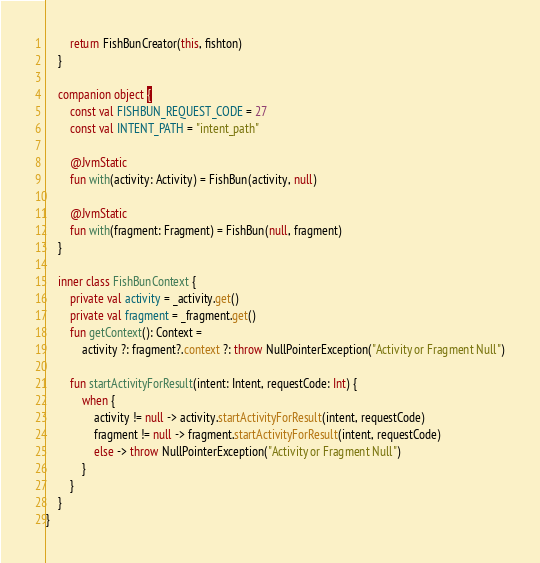<code> <loc_0><loc_0><loc_500><loc_500><_Kotlin_>        return FishBunCreator(this, fishton)
    }

    companion object {
        const val FISHBUN_REQUEST_CODE = 27
        const val INTENT_PATH = "intent_path"

        @JvmStatic
        fun with(activity: Activity) = FishBun(activity, null)

        @JvmStatic
        fun with(fragment: Fragment) = FishBun(null, fragment)
    }

    inner class FishBunContext {
        private val activity = _activity.get()
        private val fragment = _fragment.get()
        fun getContext(): Context =
            activity ?: fragment?.context ?: throw NullPointerException("Activity or Fragment Null")

        fun startActivityForResult(intent: Intent, requestCode: Int) {
            when {
                activity != null -> activity.startActivityForResult(intent, requestCode)
                fragment != null -> fragment.startActivityForResult(intent, requestCode)
                else -> throw NullPointerException("Activity or Fragment Null")
            }
        }
    }
}


</code> 